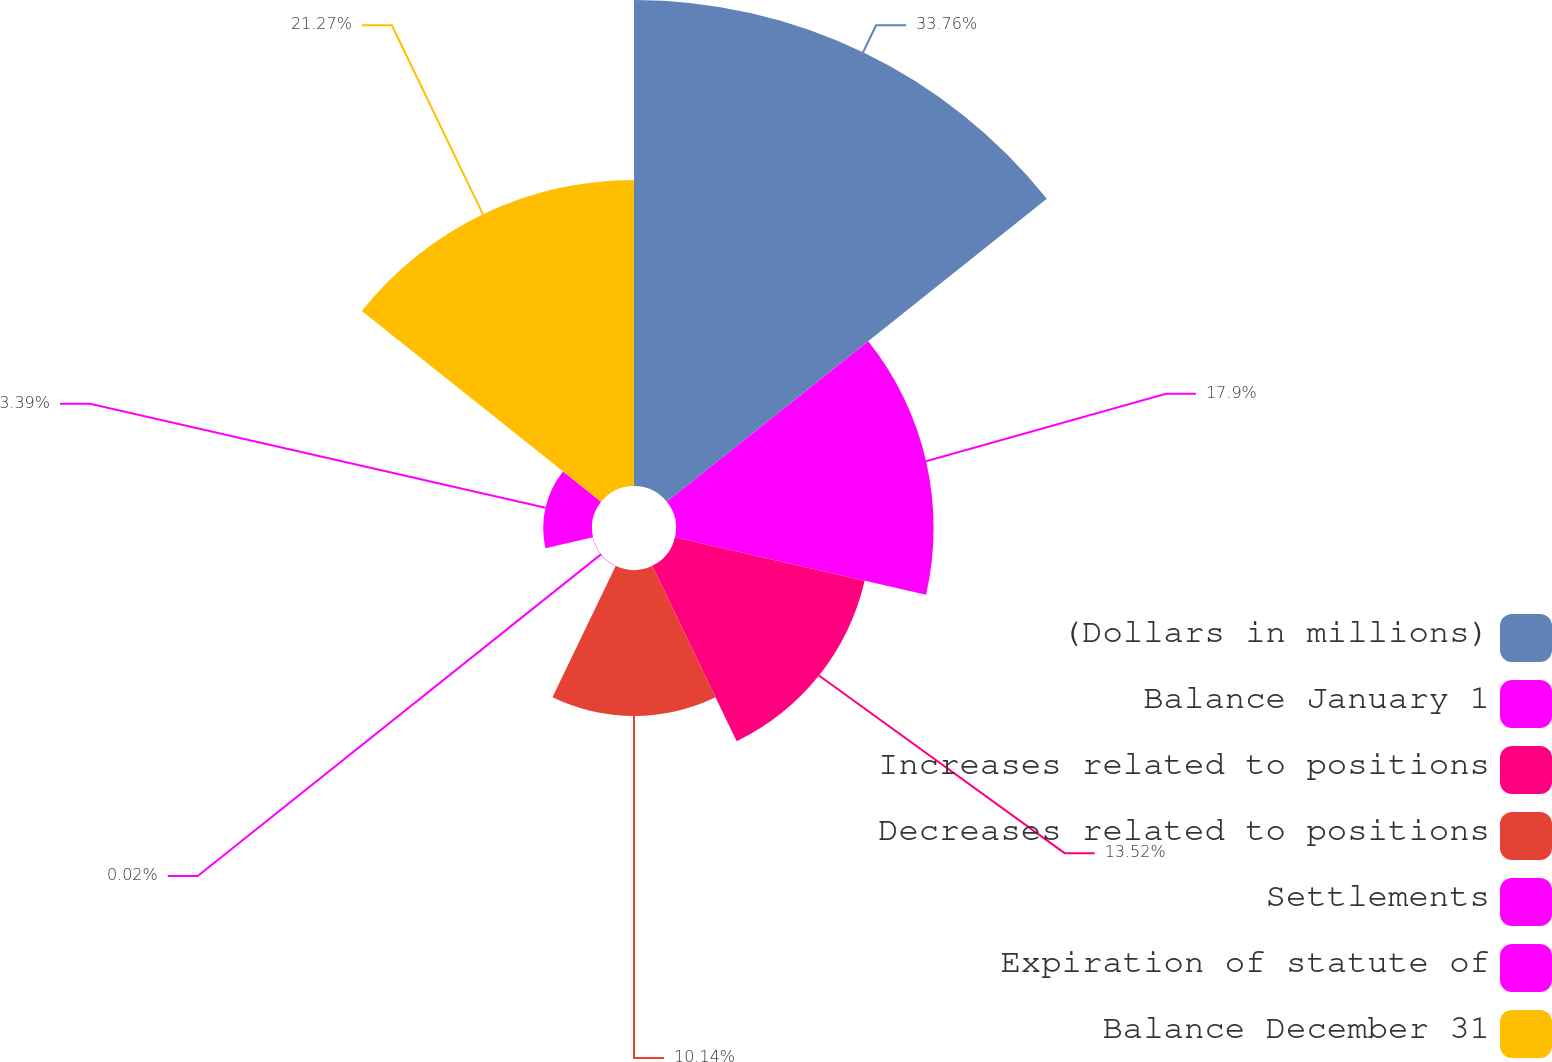Convert chart. <chart><loc_0><loc_0><loc_500><loc_500><pie_chart><fcel>(Dollars in millions)<fcel>Balance January 1<fcel>Increases related to positions<fcel>Decreases related to positions<fcel>Settlements<fcel>Expiration of statute of<fcel>Balance December 31<nl><fcel>33.77%<fcel>17.9%<fcel>13.52%<fcel>10.14%<fcel>0.02%<fcel>3.39%<fcel>21.27%<nl></chart> 